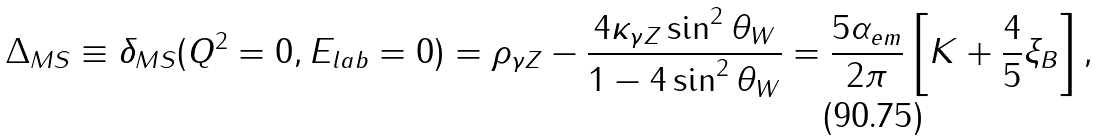<formula> <loc_0><loc_0><loc_500><loc_500>\Delta _ { M S } \equiv \delta _ { M S } ( Q ^ { 2 } = 0 , E _ { l a b } = 0 ) = \rho _ { \gamma Z } - \frac { 4 \kappa _ { \gamma Z } \sin ^ { 2 } \theta _ { W } } { 1 - 4 \sin ^ { 2 } \theta _ { W } } = \frac { 5 \alpha _ { e m } } { 2 \pi } \left [ K + \frac { 4 } { 5 } \xi _ { B } \right ] ,</formula> 